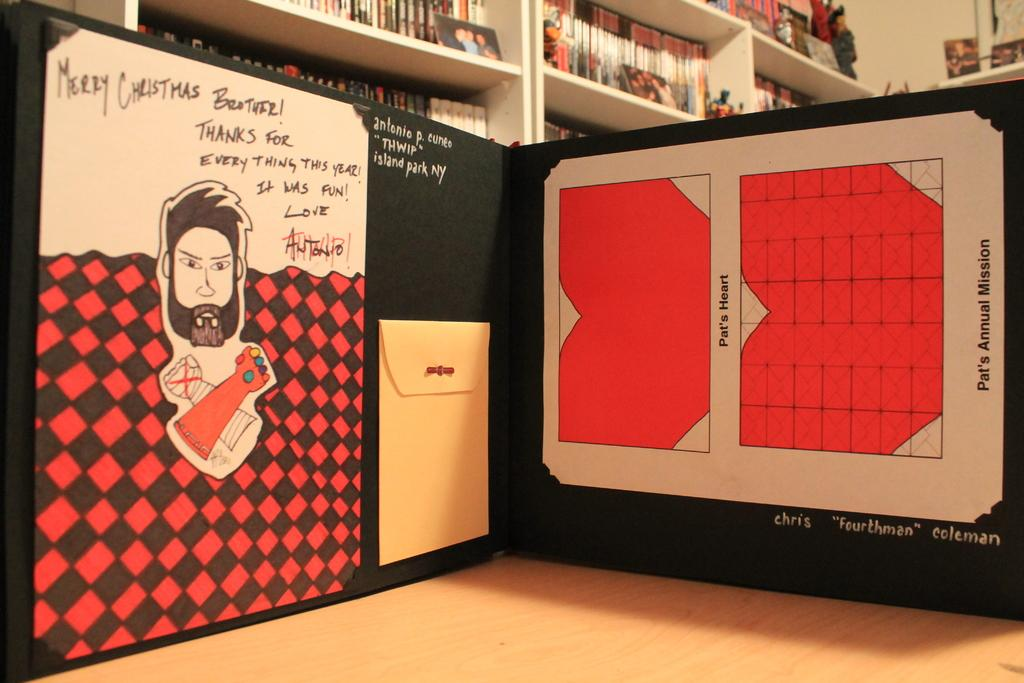Provide a one-sentence caption for the provided image. Board with a christmas picture in it and a small note. 